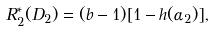<formula> <loc_0><loc_0><loc_500><loc_500>R _ { 2 } ^ { * } ( D _ { 2 } ) = ( b - 1 ) [ 1 - h ( \alpha _ { 2 } ) ] ,</formula> 